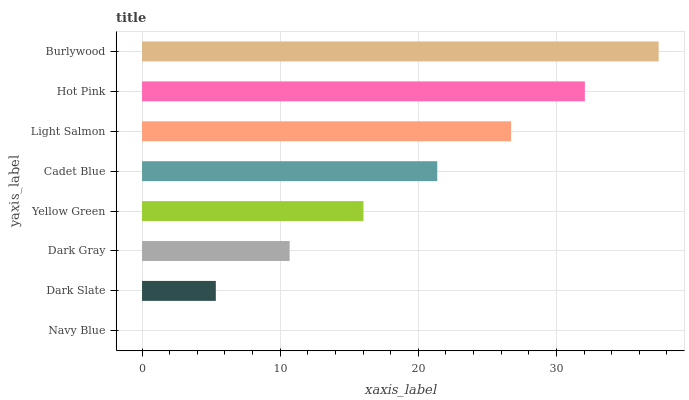Is Navy Blue the minimum?
Answer yes or no. Yes. Is Burlywood the maximum?
Answer yes or no. Yes. Is Dark Slate the minimum?
Answer yes or no. No. Is Dark Slate the maximum?
Answer yes or no. No. Is Dark Slate greater than Navy Blue?
Answer yes or no. Yes. Is Navy Blue less than Dark Slate?
Answer yes or no. Yes. Is Navy Blue greater than Dark Slate?
Answer yes or no. No. Is Dark Slate less than Navy Blue?
Answer yes or no. No. Is Cadet Blue the high median?
Answer yes or no. Yes. Is Yellow Green the low median?
Answer yes or no. Yes. Is Navy Blue the high median?
Answer yes or no. No. Is Navy Blue the low median?
Answer yes or no. No. 